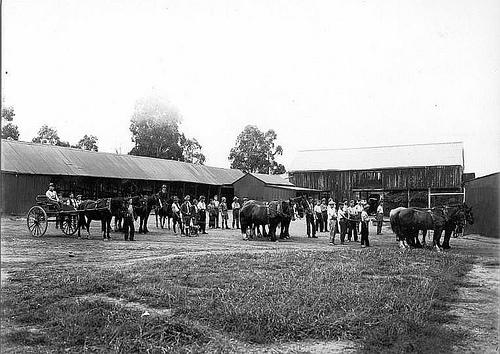What kind of animals are in the picture?
Quick response, please. Horses. Is this a horse race?
Keep it brief. No. What are the horses on the far left attached to?
Write a very short answer. Wagon. What kind of club is assembled?
Answer briefly. Horse. Is this a modern photo?
Concise answer only. No. How many horses are shown?
Write a very short answer. 4. Are they going on a skiing trip?
Quick response, please. No. Is this a contemporary scene?
Concise answer only. No. What is in the sky?
Answer briefly. Clouds. 